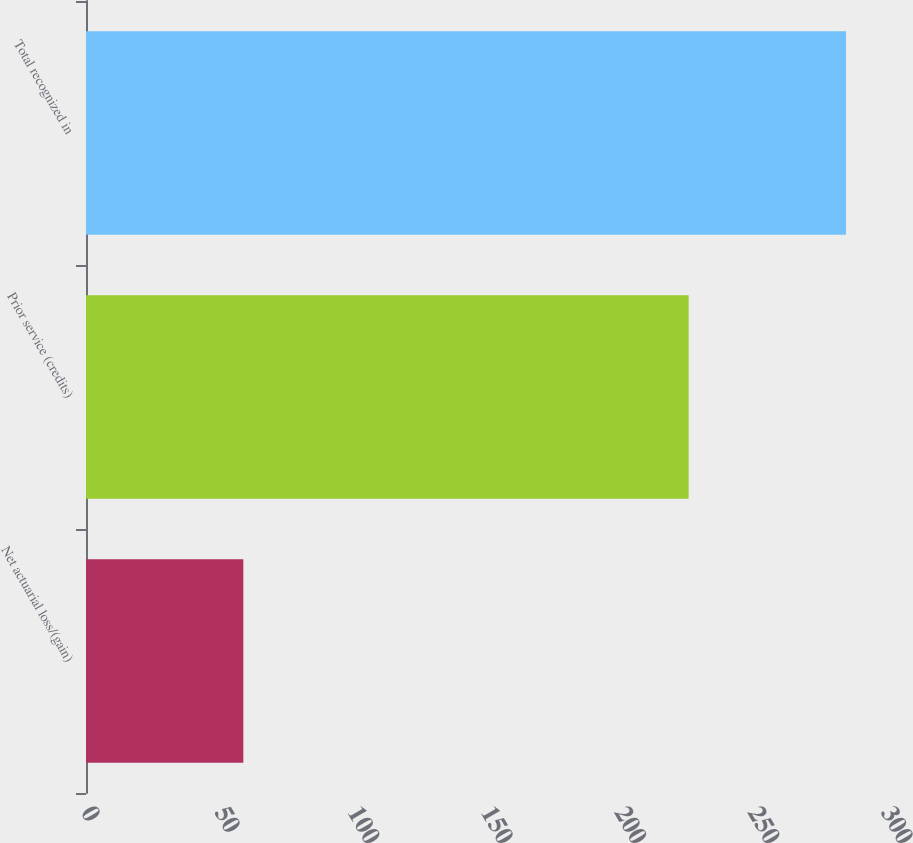Convert chart to OTSL. <chart><loc_0><loc_0><loc_500><loc_500><bar_chart><fcel>Net actuarial loss/(gain)<fcel>Prior service (credits)<fcel>Total recognized in<nl><fcel>59<fcel>226<fcel>285<nl></chart> 